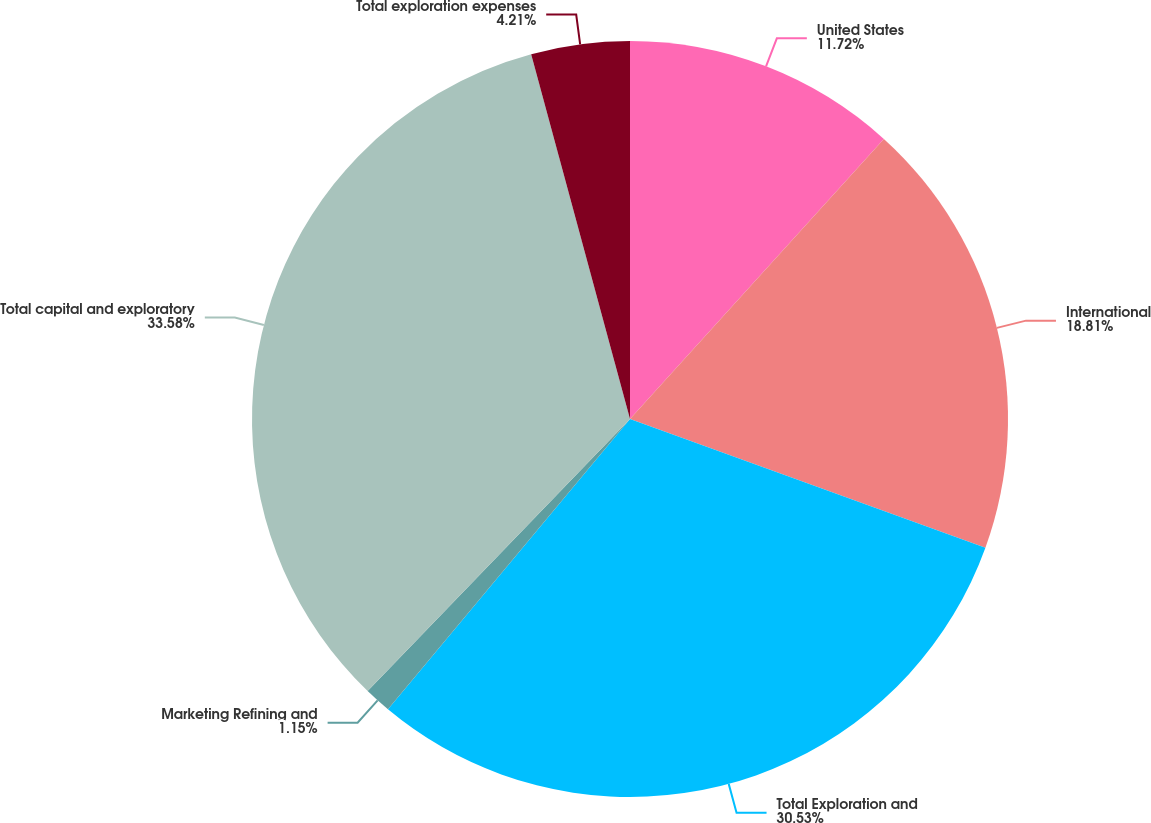Convert chart to OTSL. <chart><loc_0><loc_0><loc_500><loc_500><pie_chart><fcel>United States<fcel>International<fcel>Total Exploration and<fcel>Marketing Refining and<fcel>Total capital and exploratory<fcel>Total exploration expenses<nl><fcel>11.72%<fcel>18.81%<fcel>30.53%<fcel>1.15%<fcel>33.58%<fcel>4.21%<nl></chart> 